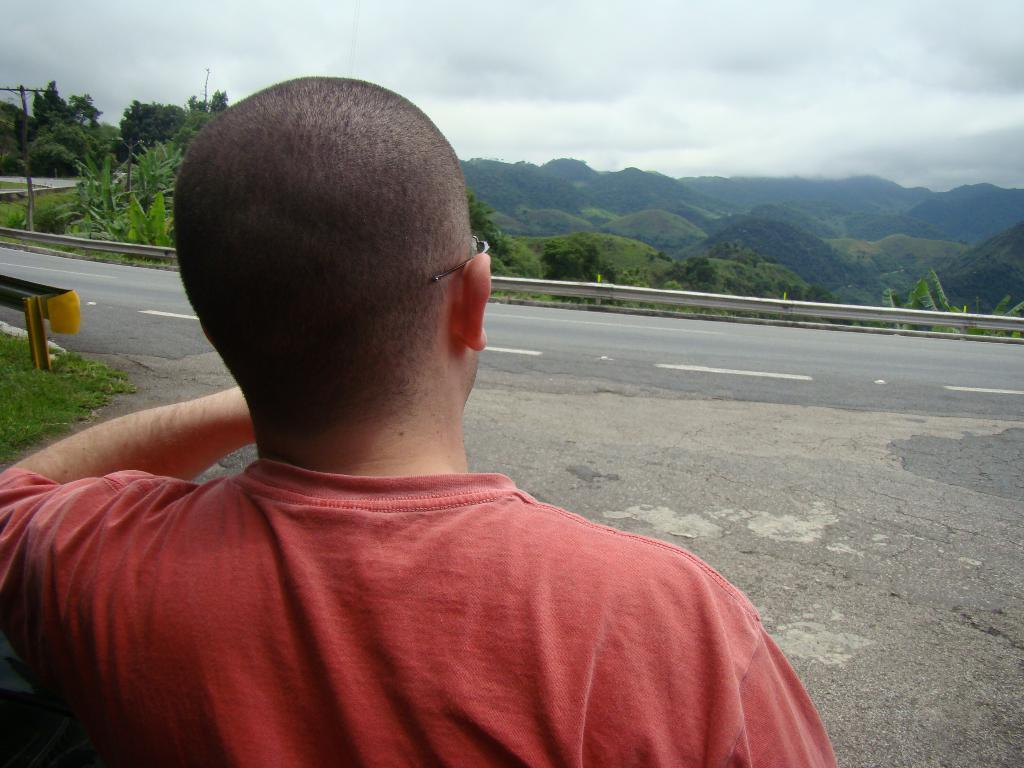What is the main subject of the image? There is a person standing on the road in the image. What can be seen in the background of the image? In the background of the image, there are current poles, plants, trees, mountains, and the sky. What type of natural features are visible in the background? The background of the image features trees and mountains. Where is the jail located in the image? There is no jail present in the image. What type of sack is being carried by the person in the image? The person in the image is not carrying a sack; they are standing on the road. 